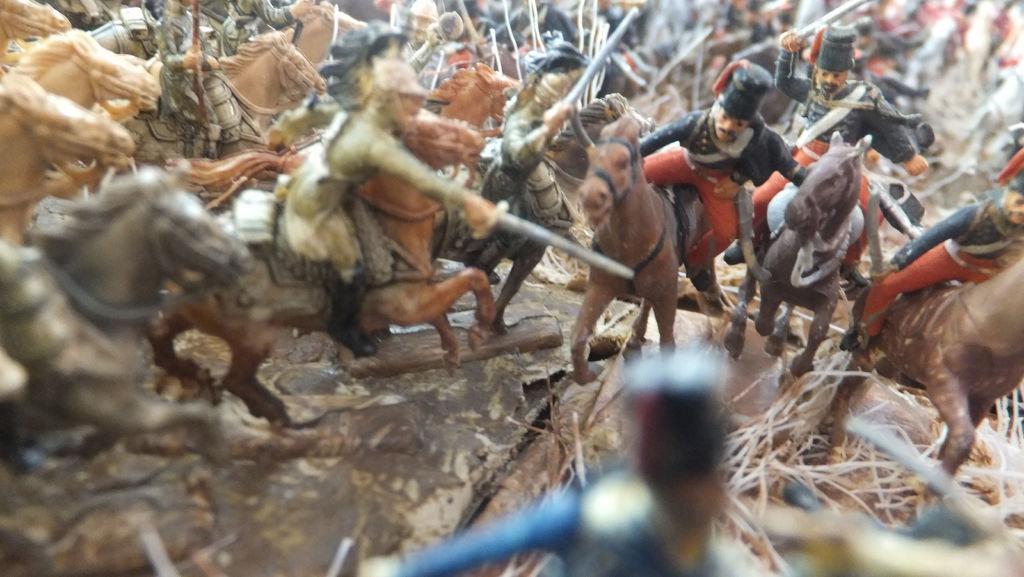Could you give a brief overview of what you see in this image? In the image we can see there are toys kept on the ground and there are human toys sitting on the horse toys. The human toys are holding sword in their hand. 